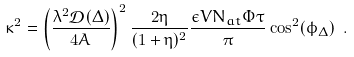<formula> <loc_0><loc_0><loc_500><loc_500>\kappa ^ { 2 } = \left ( \frac { \lambda ^ { 2 } \mathcal { D } ( \Delta ) } { 4 A } \right ) ^ { 2 } \frac { 2 \eta } { ( 1 + \eta ) ^ { 2 } } \frac { \epsilon V N _ { a t } \Phi \tau } { \pi } \cos ^ { 2 } ( \phi _ { \Delta } ) \ .</formula> 